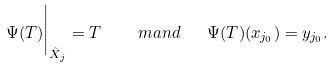Convert formula to latex. <formula><loc_0><loc_0><loc_500><loc_500>\Psi ( T ) \Big | _ { \tilde { X } _ { j } } = T \quad \ m a n d \quad \Psi ( T ) ( x _ { j _ { 0 } } ) = y _ { j _ { 0 } } .</formula> 